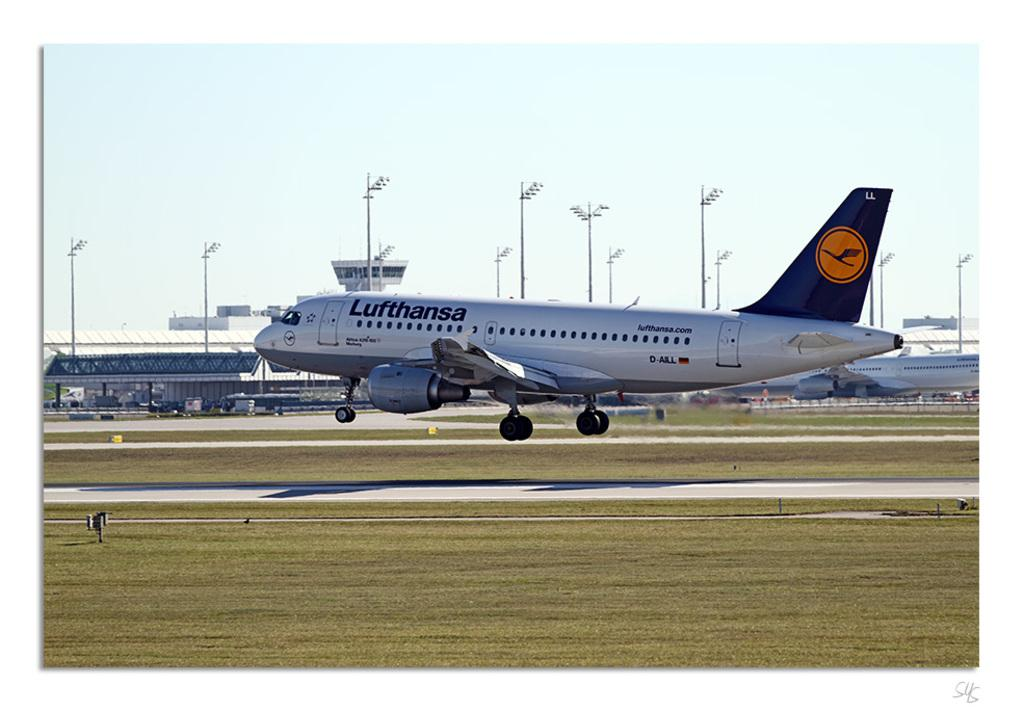What is the main subject of the image? The main subject of the image is aeroplanes. What else can be seen in the image besides the aeroplanes? There is a building and pole lights in the image. What type of vegetation is present on both sides of the runway? Grass is present on both sides of the runway. How would you describe the sky in the image? The sky is cloudy in the image. What type of silver object is being used by the spy to solve the riddle in the image? There is no silver object, spy, or riddle present in the image. 